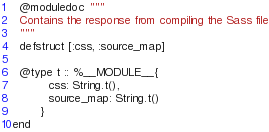<code> <loc_0><loc_0><loc_500><loc_500><_Elixir_>  @moduledoc """
  Contains the response from compiling the Sass file
  """
  defstruct [:css, :source_map]

  @type t :: %__MODULE__{
          css: String.t(),
          source_map: String.t()
        }
end
</code> 